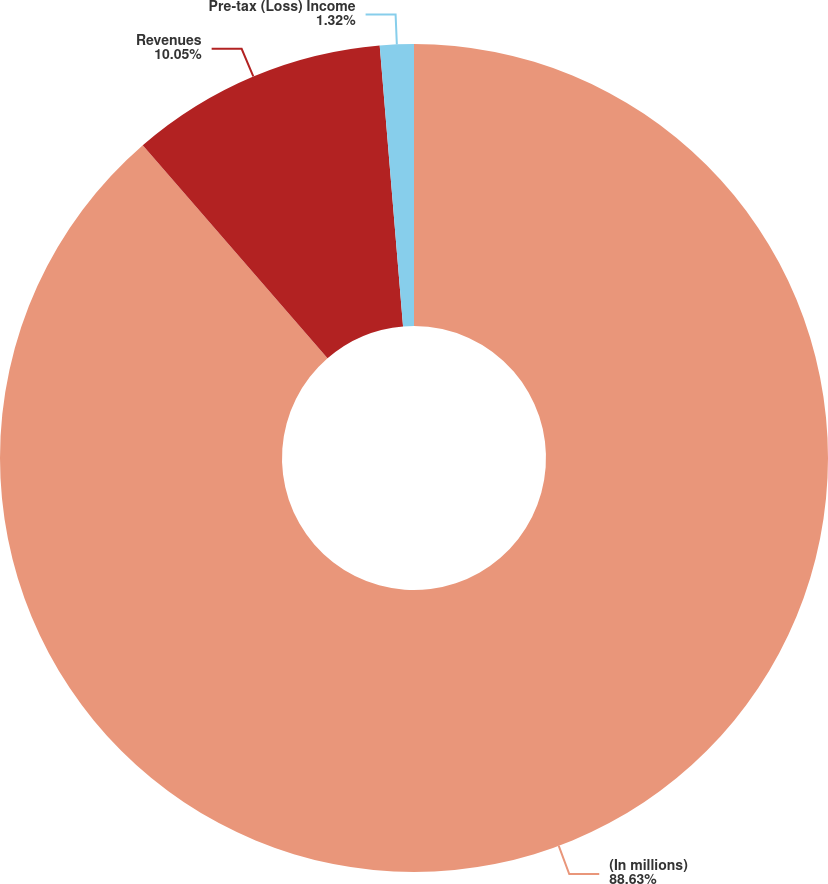<chart> <loc_0><loc_0><loc_500><loc_500><pie_chart><fcel>(In millions)<fcel>Revenues<fcel>Pre-tax (Loss) Income<nl><fcel>88.63%<fcel>10.05%<fcel>1.32%<nl></chart> 